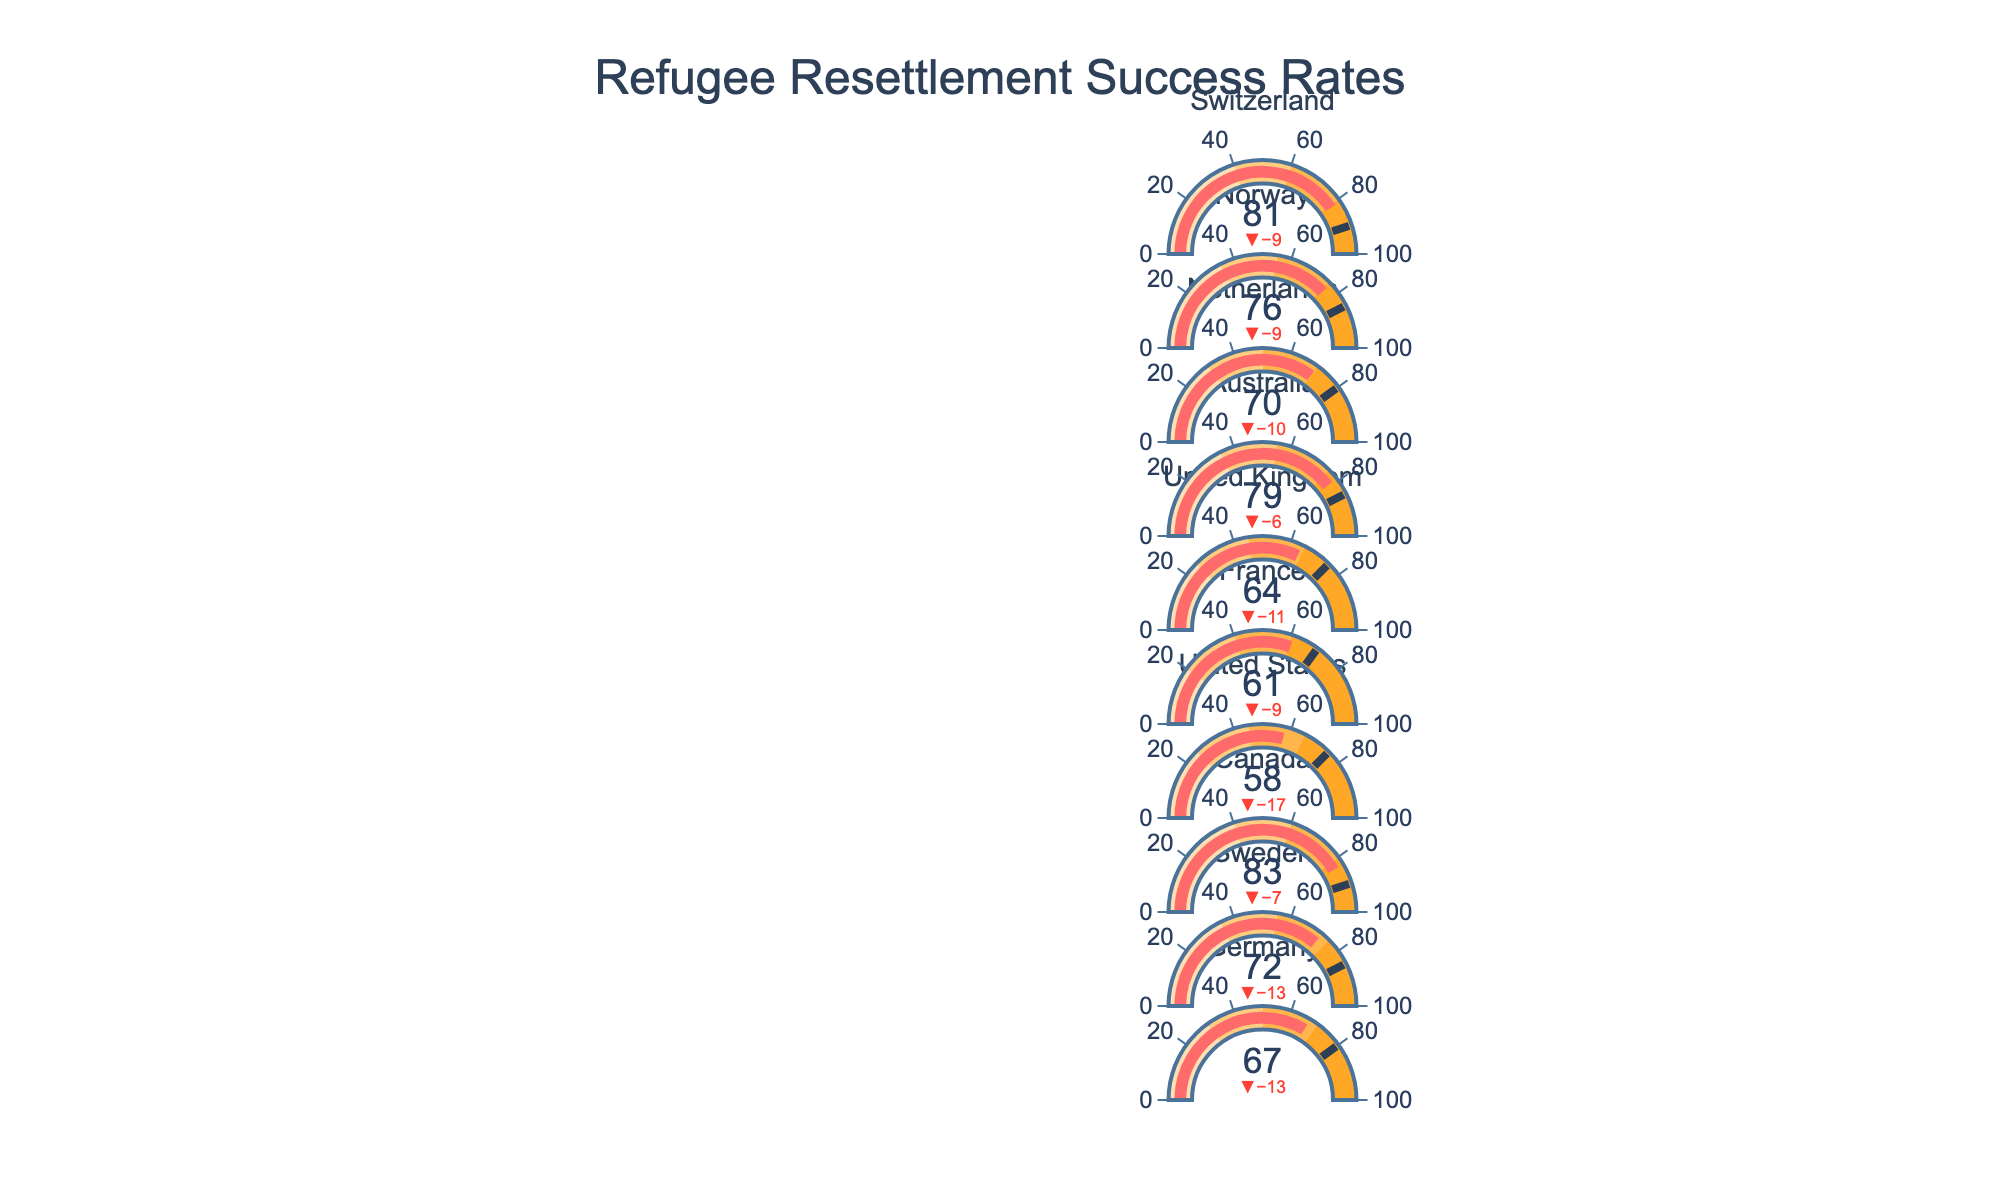What's the title of the figure? The title of the figure is displayed prominently at the top. It should clearly state what the chart is about.
Answer: Refugee Resettlement Success Rates How many countries are represented in the figure? The number of unique entries or labels displayed on the y-axis corresponds to the countries represented in the figure.
Answer: 10 Which country has the highest refugee resettlement success rate? Look at the "Actual" value for each country and identify the one with the highest value.
Answer: Canada Which country's actual resettlement success is closest to its target value? Calculate the difference between the actual and target values for each country and find the smallest difference.
Answer: Switzerland By how much did Canada exceed its target resettlement success rate? Subtract Canada's target rate from its actual rate.
Answer: -7 (83 - 90) Which countries exceeded their "Good" resettlement success threshold? Check the colors on the Bullet Chart that indicate the "Good" threshold for each country and see which countries' actual values are in this range.
Answer: Canada, Australia, Switzerland What is the average actual resettlement success rate of all countries? Add up the actual values for all countries and divide by the total number of countries (10).
Answer: (67 + 72 + 83 + 58 + 61 + 64 + 79 + 70 + 76 + 81) / 10 = 71.1 Which country has the lowest target resettlement success rate? Compare the target values for all countries and find the lowest one.
Answer: France How many countries did not reach their fair resettlement success threshold? Check the actual values against the fair success range for each country and count how many did not meet it.
Answer: 1 (United States) Which country had the largest gap between its actual resettlement success rate and the 'Poor' threshold? For each country, subtract the 'Poor' threshold value from the actual value and identify the largest difference.
Answer: Canada (83 - 40 = 43) 